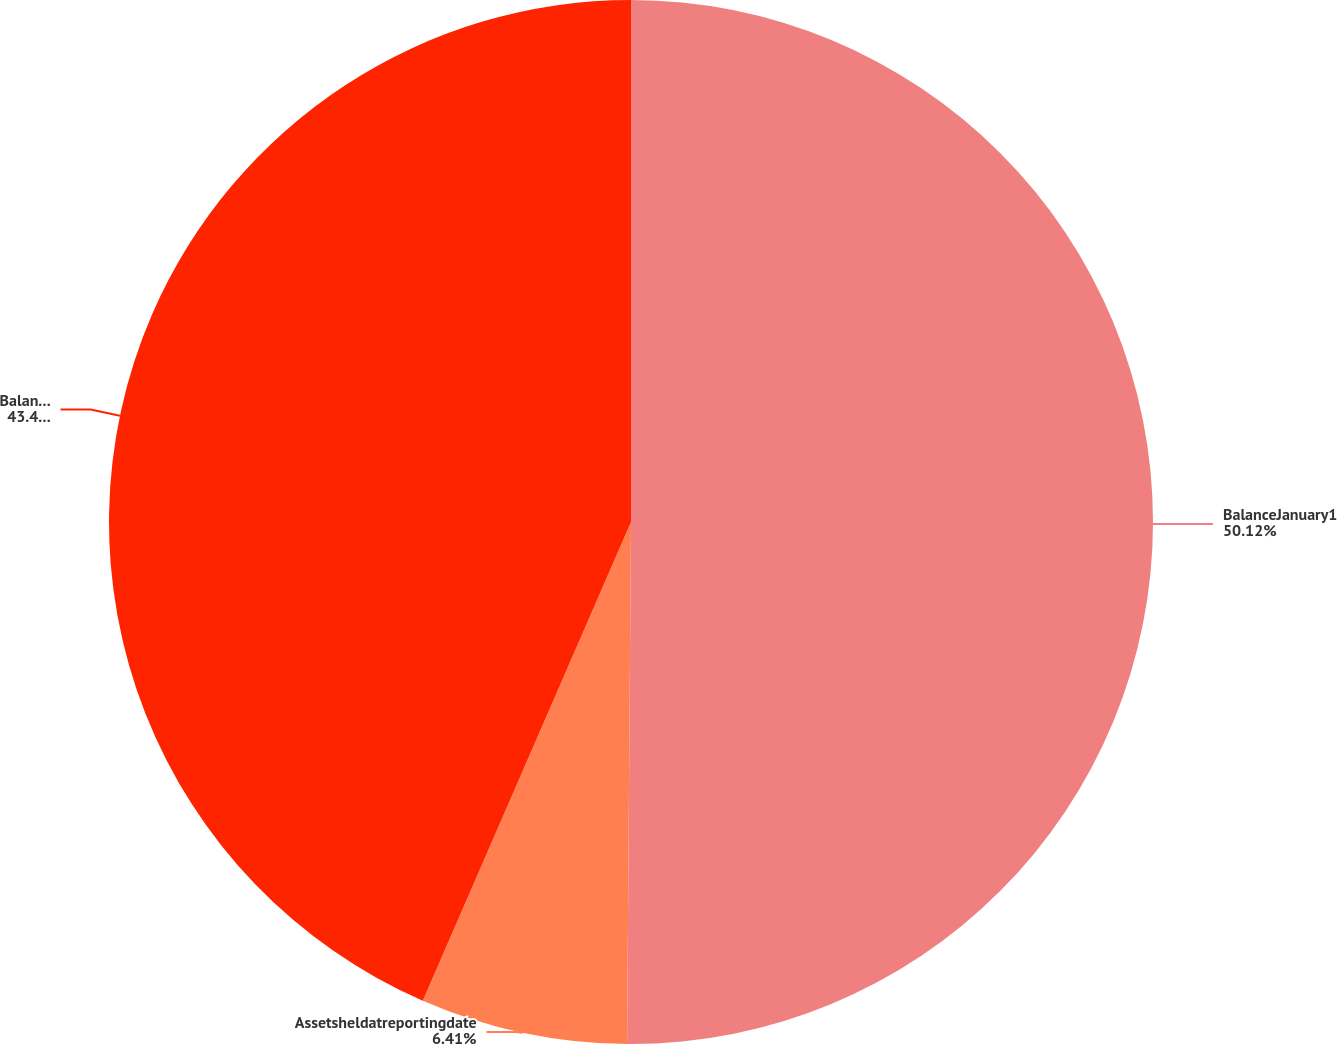Convert chart. <chart><loc_0><loc_0><loc_500><loc_500><pie_chart><fcel>BalanceJanuary1<fcel>Assetsheldatreportingdate<fcel>BalanceatDecember31<nl><fcel>50.12%<fcel>6.41%<fcel>43.47%<nl></chart> 